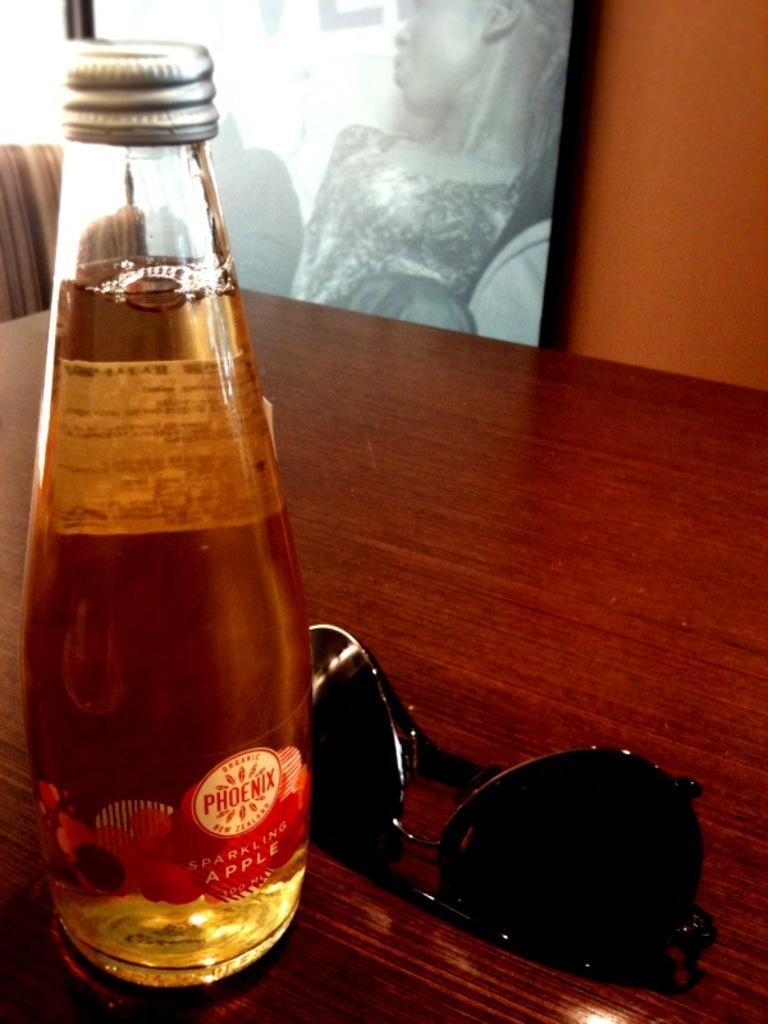Could you give a brief overview of what you see in this image? In this image there is a bottle labelled as phoenix having drink in it is placed on a table having goggles on it. At the background there is a picture frame having person is attached to the wall. 